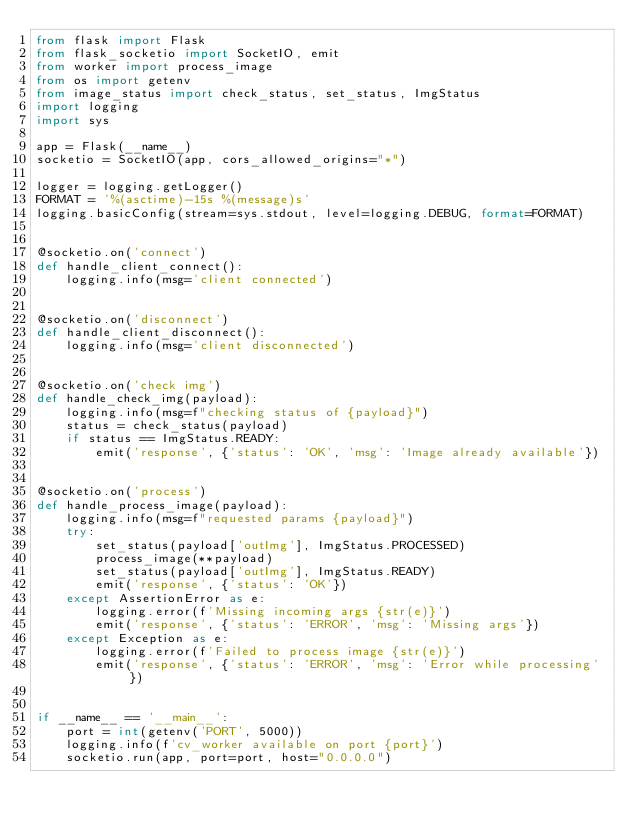Convert code to text. <code><loc_0><loc_0><loc_500><loc_500><_Python_>from flask import Flask
from flask_socketio import SocketIO, emit
from worker import process_image
from os import getenv
from image_status import check_status, set_status, ImgStatus
import logging
import sys

app = Flask(__name__)
socketio = SocketIO(app, cors_allowed_origins="*")

logger = logging.getLogger()
FORMAT = '%(asctime)-15s %(message)s'
logging.basicConfig(stream=sys.stdout, level=logging.DEBUG, format=FORMAT)


@socketio.on('connect')
def handle_client_connect():
    logging.info(msg='client connected')


@socketio.on('disconnect')
def handle_client_disconnect():
    logging.info(msg='client disconnected')


@socketio.on('check img')
def handle_check_img(payload):
    logging.info(msg=f"checking status of {payload}")
    status = check_status(payload)
    if status == ImgStatus.READY:
        emit('response', {'status': 'OK', 'msg': 'Image already available'})


@socketio.on('process')
def handle_process_image(payload):
    logging.info(msg=f"requested params {payload}")
    try:
        set_status(payload['outImg'], ImgStatus.PROCESSED)
        process_image(**payload)
        set_status(payload['outImg'], ImgStatus.READY)
        emit('response', {'status': 'OK'})
    except AssertionError as e:
        logging.error(f'Missing incoming args {str(e)}')
        emit('response', {'status': 'ERROR', 'msg': 'Missing args'})
    except Exception as e:
        logging.error(f'Failed to process image {str(e)}')
        emit('response', {'status': 'ERROR', 'msg': 'Error while processing'})


if __name__ == '__main__':
    port = int(getenv('PORT', 5000))
    logging.info(f'cv_worker available on port {port}')
    socketio.run(app, port=port, host="0.0.0.0")
</code> 